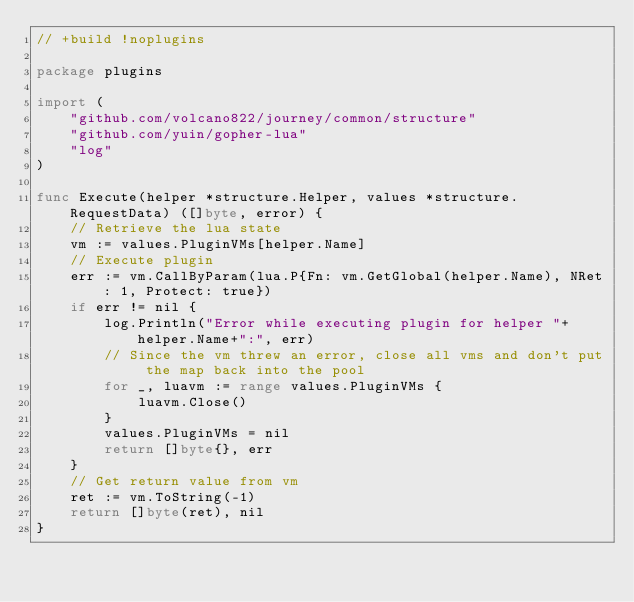Convert code to text. <code><loc_0><loc_0><loc_500><loc_500><_Go_>// +build !noplugins

package plugins

import (
	"github.com/volcano822/journey/common/structure"
	"github.com/yuin/gopher-lua"
	"log"
)

func Execute(helper *structure.Helper, values *structure.RequestData) ([]byte, error) {
	// Retrieve the lua state
	vm := values.PluginVMs[helper.Name]
	// Execute plugin
	err := vm.CallByParam(lua.P{Fn: vm.GetGlobal(helper.Name), NRet: 1, Protect: true})
	if err != nil {
		log.Println("Error while executing plugin for helper "+helper.Name+":", err)
		// Since the vm threw an error, close all vms and don't put the map back into the pool
		for _, luavm := range values.PluginVMs {
			luavm.Close()
		}
		values.PluginVMs = nil
		return []byte{}, err
	}
	// Get return value from vm
	ret := vm.ToString(-1)
	return []byte(ret), nil
}
</code> 